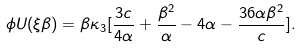<formula> <loc_0><loc_0><loc_500><loc_500>\phi U ( \xi \beta ) = \beta \kappa _ { 3 } [ \frac { 3 c } { 4 \alpha } + \frac { \beta ^ { 2 } } { \alpha } - 4 \alpha - \frac { 3 6 \alpha \beta ^ { 2 } } { c } ] .</formula> 